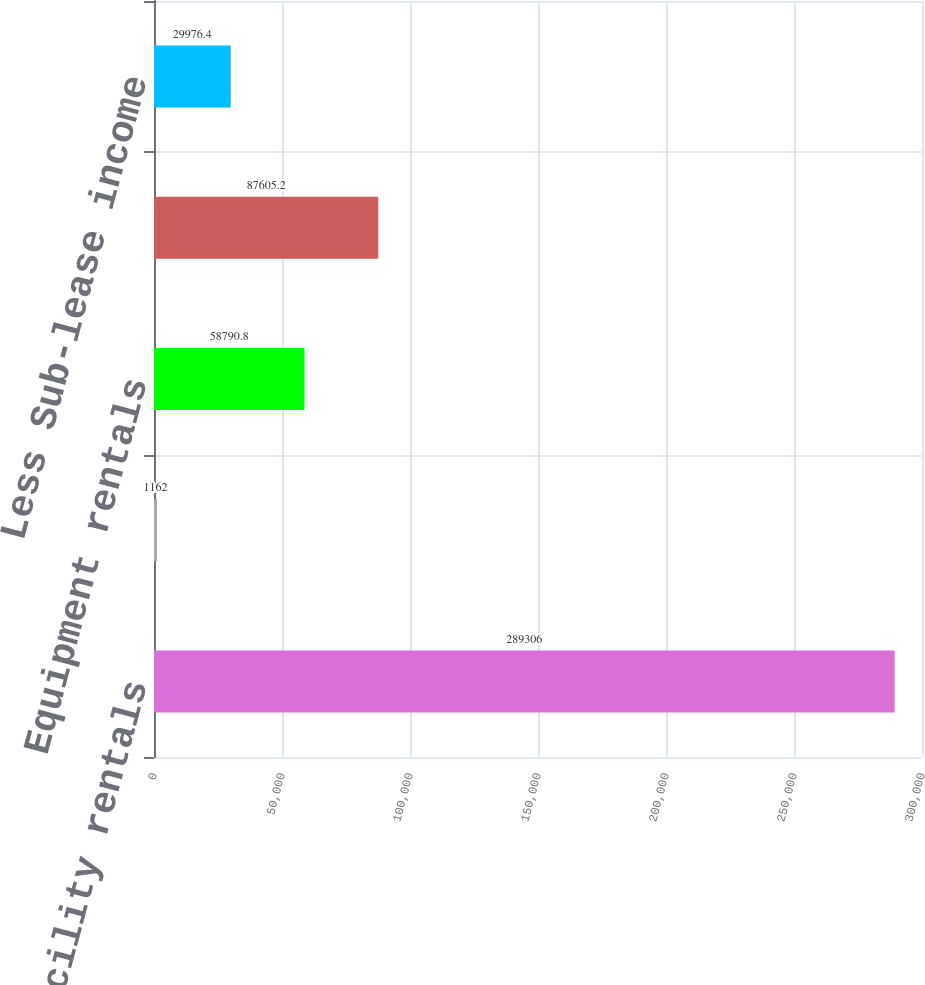Convert chart to OTSL. <chart><loc_0><loc_0><loc_500><loc_500><bar_chart><fcel>Minimum facility rentals<fcel>Contingency facility rentals<fcel>Equipment rentals<fcel>Vehicle rentals<fcel>Less Sub-lease income<nl><fcel>289306<fcel>1162<fcel>58790.8<fcel>87605.2<fcel>29976.4<nl></chart> 